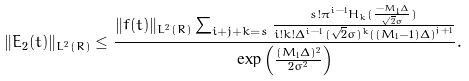<formula> <loc_0><loc_0><loc_500><loc_500>\| E _ { 2 } ( t ) \| _ { L ^ { 2 } ( R ) } \leq \frac { \| f ( t ) \| _ { L ^ { 2 } ( R ) } \sum _ { i + j + k = s } \frac { s ! { \pi } ^ { i - 1 } H _ { k } ( \frac { - M _ { 1 } \Delta } { \sqrt { 2 } \sigma } ) } { i ! k ! { \Delta } ^ { i - 1 } ( \sqrt { 2 } \sigma ) ^ { k } \left ( ( M _ { 1 } - 1 ) \Delta \right ) ^ { j + 1 } } } { \exp \left ( \frac { ( M _ { 1 } \Delta ) ^ { 2 } } { 2 { \sigma } ^ { 2 } } \right ) } .</formula> 